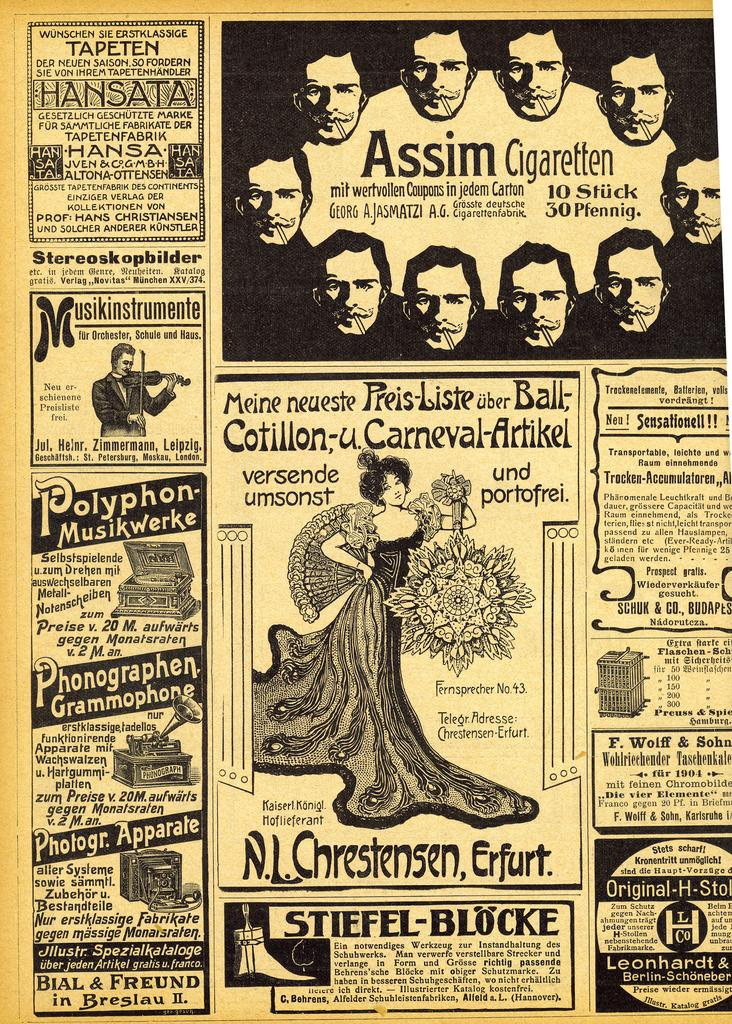<image>
Create a compact narrative representing the image presented. A page out of an old newspaper showing many advertisements, including on for Phonographen Grammophone. 